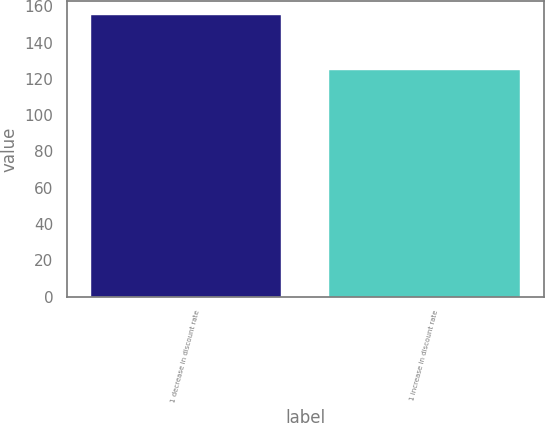Convert chart. <chart><loc_0><loc_0><loc_500><loc_500><bar_chart><fcel>1 decrease in discount rate<fcel>1 increase in discount rate<nl><fcel>155<fcel>125<nl></chart> 